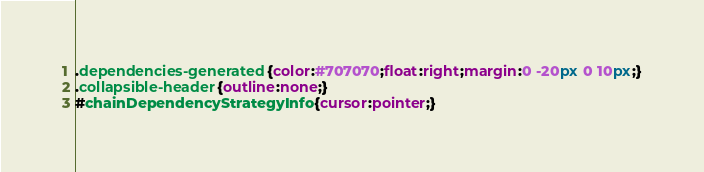<code> <loc_0><loc_0><loc_500><loc_500><_CSS_>.dependencies-generated{color:#707070;float:right;margin:0 -20px 0 10px;}
.collapsible-header{outline:none;}
#chainDependencyStrategyInfo{cursor:pointer;}
</code> 